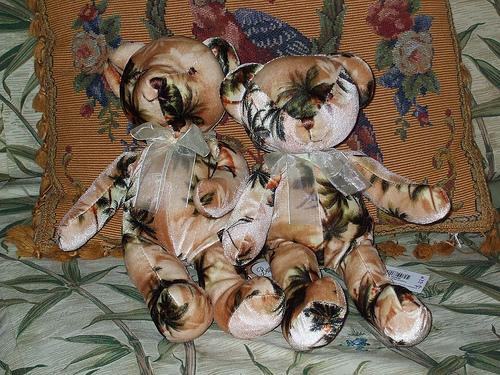Enumerate how the teddy bears are positioned relative to a particular object. Teddy bears are sitting up, leaning against a yellow embroidered pillow, and resting on a brown pillow with flower decorations. What are the different types of patterns found on the objects in the image? There are palm tree print, floral, bamboo print, green leaves, and brown vines patterns on various objects in the image. Mention the prominent object colors in the scene and their associated object types. Brown teddy bears with leaf patterns, green and tan comforters, a brown pillow with flowers, a white gauzy bow, and a white tag on a toy. Identify the distinct features of one of the teddy bears in the image. The teddy bear has a brown nose, brown eyes, a white gauzy bow, a black and brown face, and a white tag with black writing. Describe the various fabric textures found in the scene. The scene includes a row of tassles, translucent bows, bamboo print on the comforter, and a mix of floral and leaf patterns on other objects. How many teddy bears are there in the image, and what are their main features? There are two teddy bears; they have brown eyes, brown noses, white bows, white tags, and leaf patterns on their bodies. What emotions could be associated with this image? Comfort, warmth, and coziness are emotions that could be associated with this image of teddy bears, a pillow, and a comforter. What are the distinguishing characteristics of the pillow in the scene? The pillow is yellow with brown tassles, embroidered, and decorated with flowers. Discuss the interactions between the teddy bears and their surroundings. Teddy bears are sitting up, leaning against a pillow, and resting on a brown pillow. They are surrounded by a green and tan comforter with leaf patterns and a white tag. A small white dog with pointy ears has snuck into the scene, cuddling up near the teddy bears' legs. See if you can find it nestled within the embrace of the pillow. No, it's not mentioned in the image. 